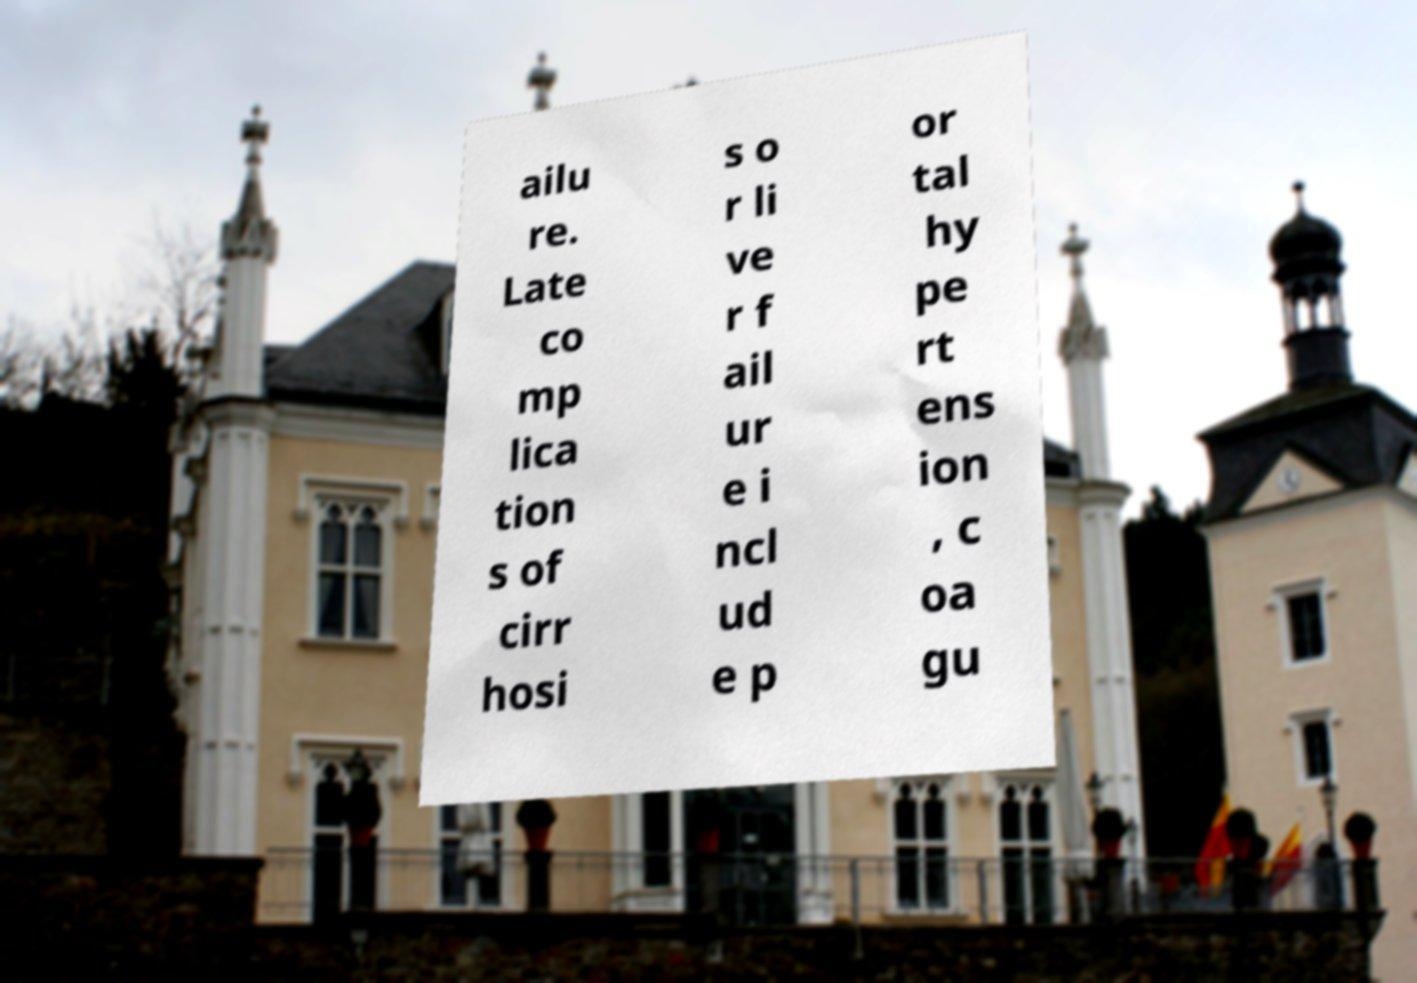Please read and relay the text visible in this image. What does it say? ailu re. Late co mp lica tion s of cirr hosi s o r li ve r f ail ur e i ncl ud e p or tal hy pe rt ens ion , c oa gu 